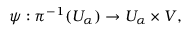Convert formula to latex. <formula><loc_0><loc_0><loc_500><loc_500>\psi \colon \pi ^ { - 1 } ( U _ { \alpha } ) \rightarrow U _ { \alpha } \times V ,</formula> 